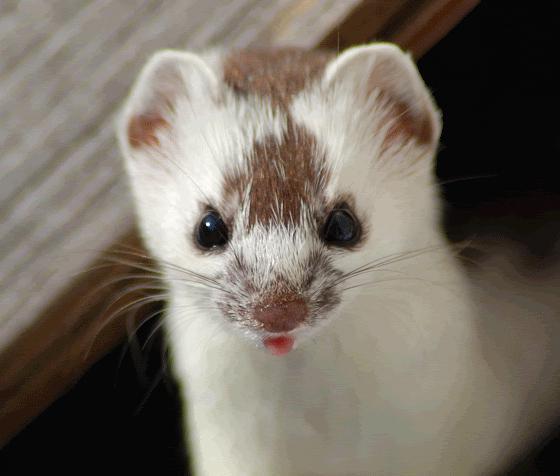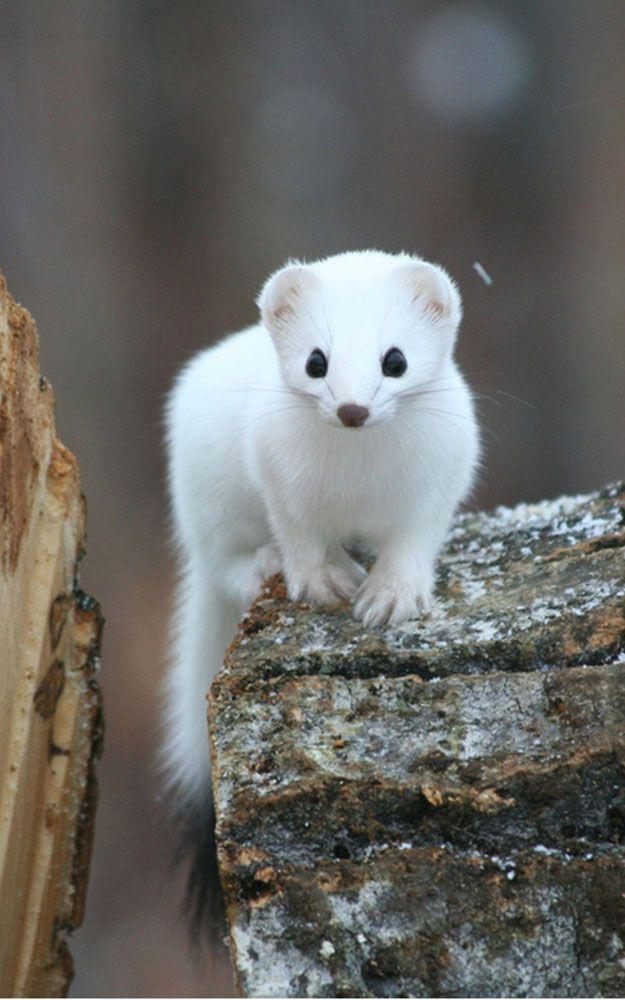The first image is the image on the left, the second image is the image on the right. Given the left and right images, does the statement "One ferret is on a rock." hold true? Answer yes or no. Yes. The first image is the image on the left, the second image is the image on the right. Considering the images on both sides, is "Each image shows a single forward-turned ferret, and at least one ferret has solid-white fur." valid? Answer yes or no. Yes. 